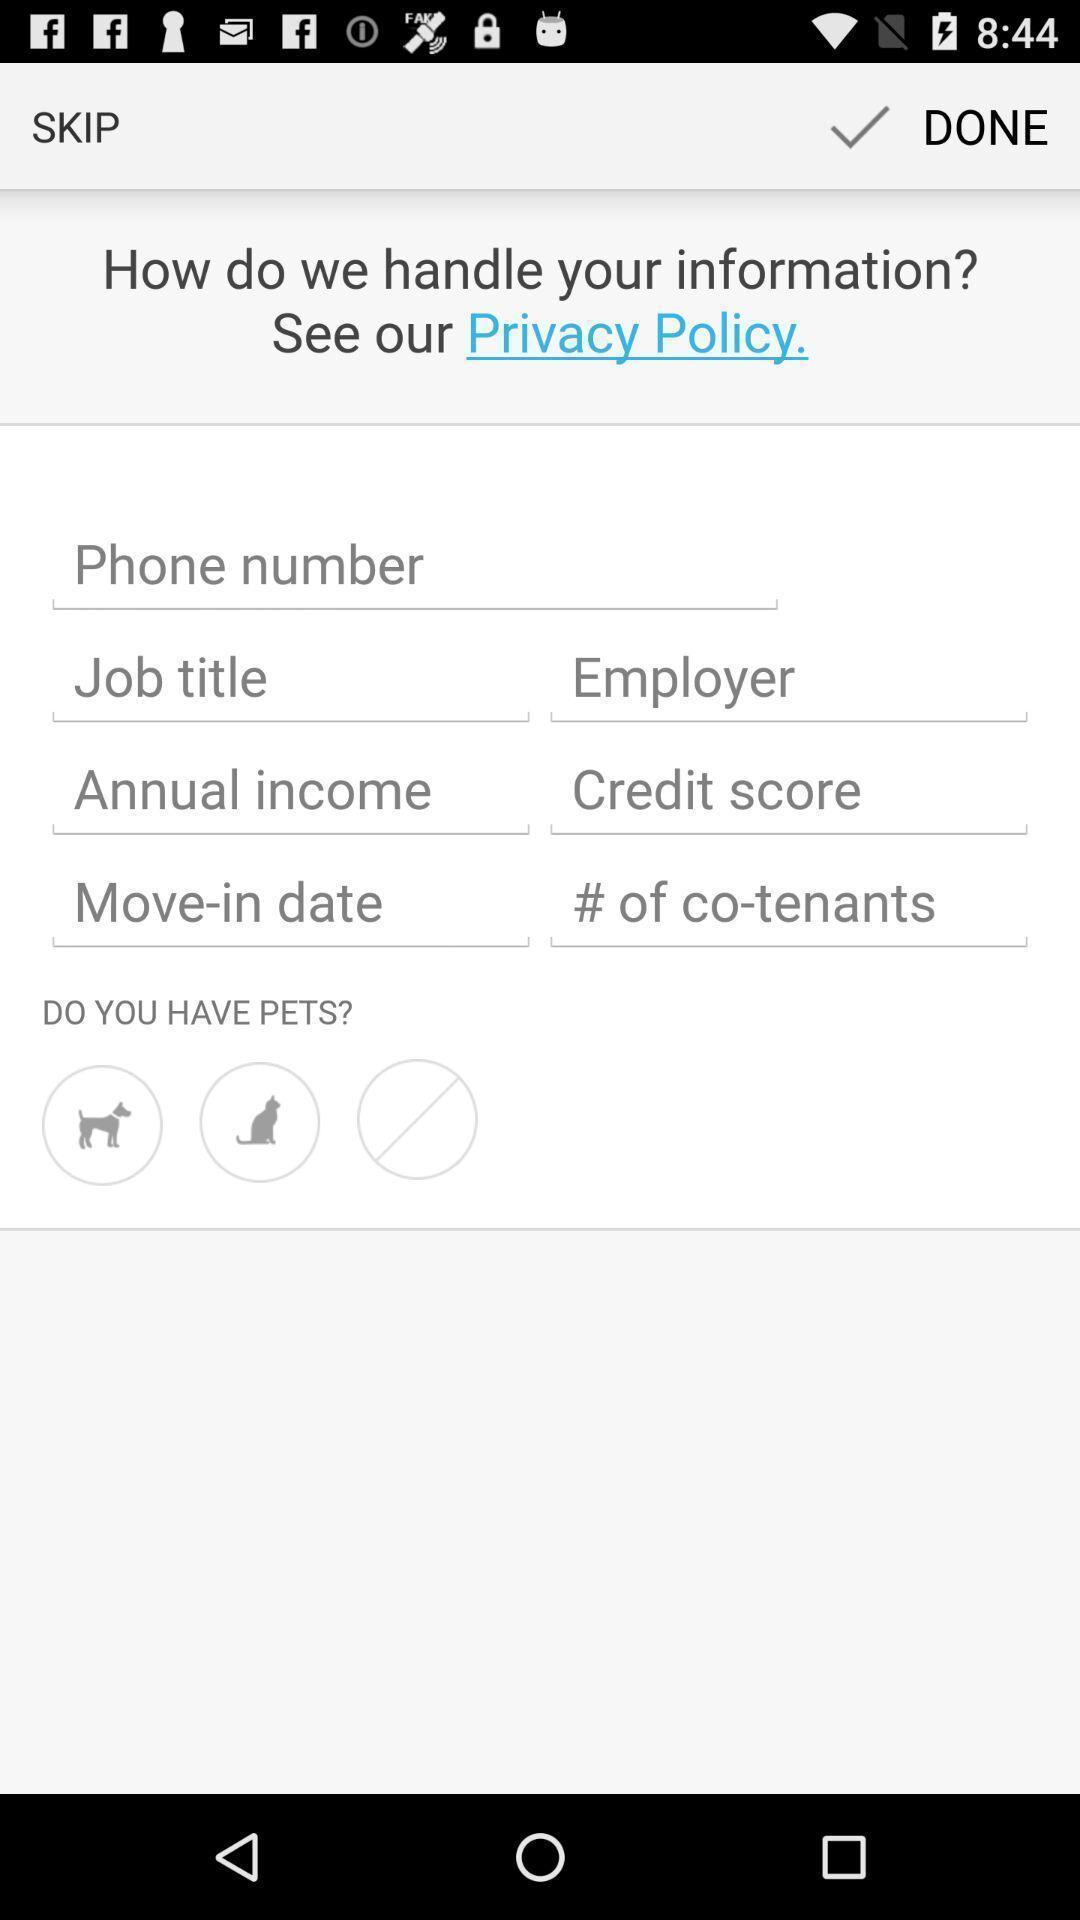Provide a description of this screenshot. Page displays to see policies for information. 